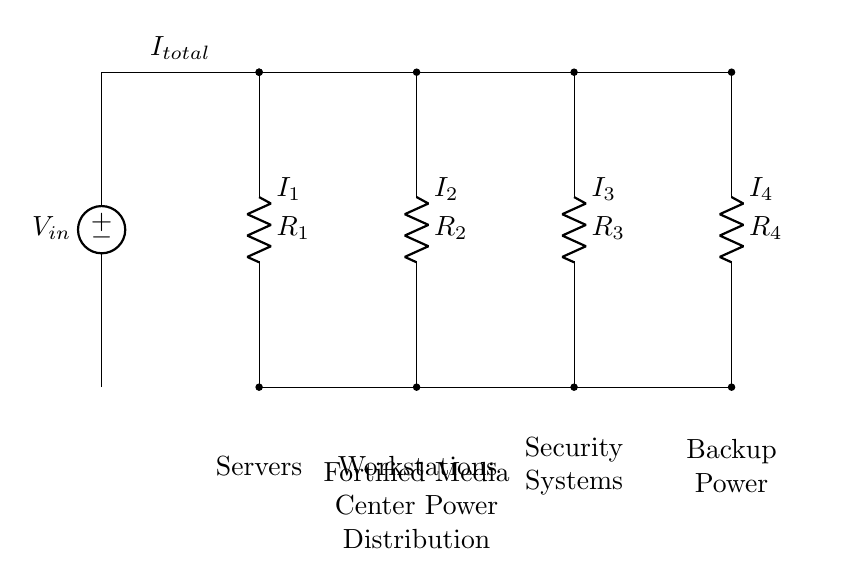What is the total current supplied in this circuit? The total current, denoted as I total, is illustrated in the circuit. It is seen flowing into the parallel connection from the power source.
Answer: I total How many resistors are connected in this circuit? There are four resistors indicated in the circuit diagram: R1, R2, R3, and R4. Each resistor is represented as a branch in the parallel configuration.
Answer: Four What is the role of resistors in this circuit design? Resistors R1, R2, R3, and R4 serve to divide the total current into separate branches, allowing different components (servers, workstations, security systems, and backup power) to receive power.
Answer: Current division Which component receives the highest current? The component with the lowest resistance will receive the highest current, as current divides among parallel resistors inversely to their resistance values. This requires calculation based on values.
Answer: Dependent on resistor values How is the total voltage across each branch in this design? In a parallel circuit, the voltage across each branch, including R1, R2, R3, and R4, remains constant and equal to the supply voltage. Therefore, the voltage across each resistor is the same as the input voltage.
Answer: Equal to V in What happens if one branch, like R1, fails? If one branch such as R1 fails, the current will continue to flow through the other branches R2, R3, and R4, maintaining operation for those components. However, the total current from the source will decrease because one path is lost.
Answer: Other branches function What is the purpose of a current divider in this circuit? The current divider ensures that the total current is distributed and balanced among the different components in the media center, allowing for efficient power management and preventing overload on any single branch.
Answer: Efficient power distribution 